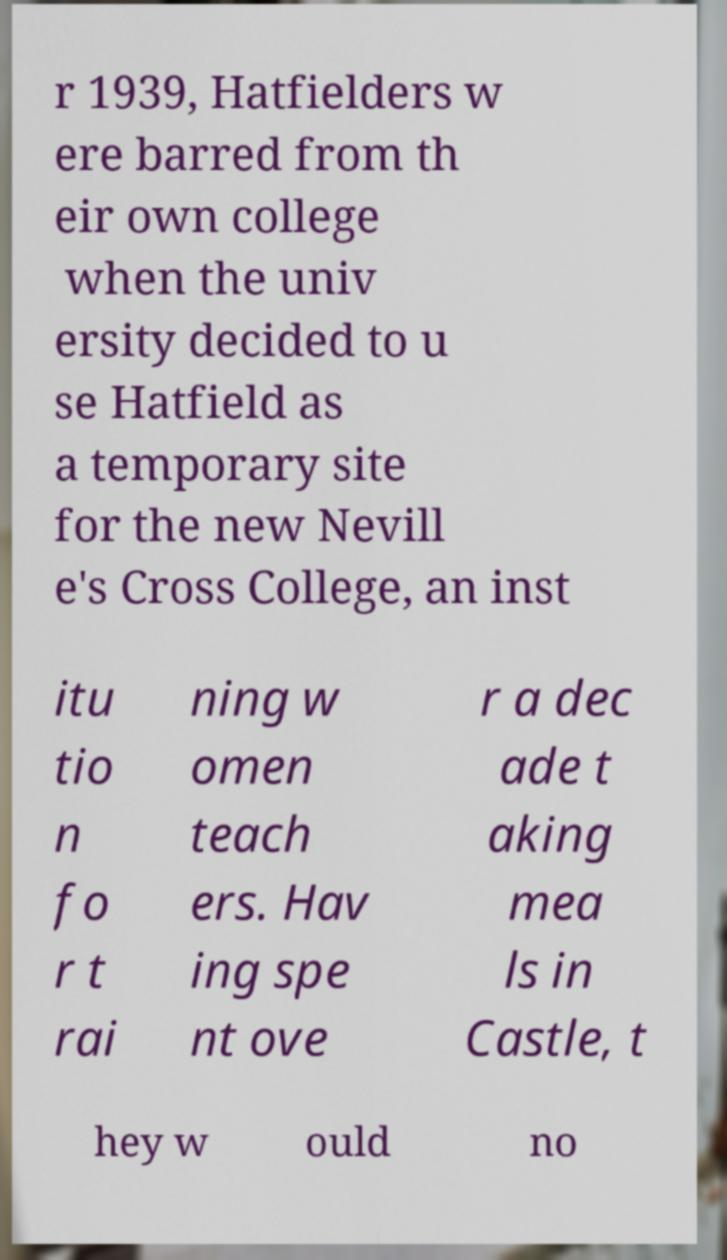Can you accurately transcribe the text from the provided image for me? r 1939, Hatfielders w ere barred from th eir own college when the univ ersity decided to u se Hatfield as a temporary site for the new Nevill e's Cross College, an inst itu tio n fo r t rai ning w omen teach ers. Hav ing spe nt ove r a dec ade t aking mea ls in Castle, t hey w ould no 